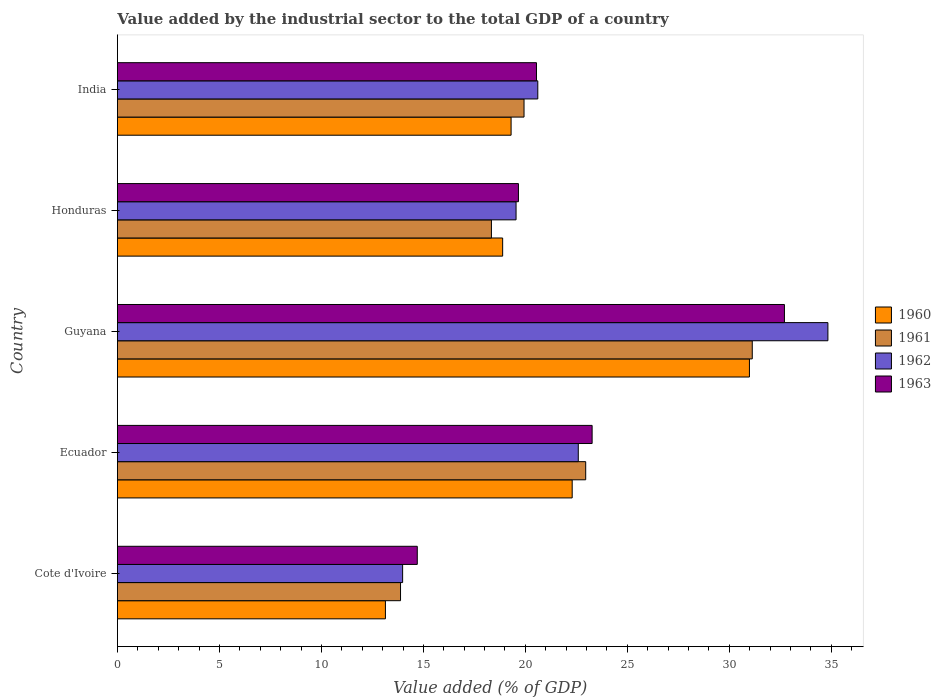How many different coloured bars are there?
Give a very brief answer. 4. How many groups of bars are there?
Make the answer very short. 5. Are the number of bars per tick equal to the number of legend labels?
Ensure brevity in your answer.  Yes. How many bars are there on the 2nd tick from the bottom?
Offer a very short reply. 4. What is the label of the 4th group of bars from the top?
Offer a terse response. Ecuador. In how many cases, is the number of bars for a given country not equal to the number of legend labels?
Offer a very short reply. 0. What is the value added by the industrial sector to the total GDP in 1963 in Cote d'Ivoire?
Provide a succinct answer. 14.7. Across all countries, what is the maximum value added by the industrial sector to the total GDP in 1963?
Keep it short and to the point. 32.7. Across all countries, what is the minimum value added by the industrial sector to the total GDP in 1963?
Ensure brevity in your answer.  14.7. In which country was the value added by the industrial sector to the total GDP in 1962 maximum?
Give a very brief answer. Guyana. In which country was the value added by the industrial sector to the total GDP in 1961 minimum?
Make the answer very short. Cote d'Ivoire. What is the total value added by the industrial sector to the total GDP in 1961 in the graph?
Offer a very short reply. 106.23. What is the difference between the value added by the industrial sector to the total GDP in 1963 in Cote d'Ivoire and that in India?
Make the answer very short. -5.84. What is the difference between the value added by the industrial sector to the total GDP in 1962 in Honduras and the value added by the industrial sector to the total GDP in 1963 in Ecuador?
Make the answer very short. -3.73. What is the average value added by the industrial sector to the total GDP in 1960 per country?
Keep it short and to the point. 20.92. What is the difference between the value added by the industrial sector to the total GDP in 1962 and value added by the industrial sector to the total GDP in 1960 in Cote d'Ivoire?
Your answer should be very brief. 0.84. What is the ratio of the value added by the industrial sector to the total GDP in 1963 in Guyana to that in Honduras?
Provide a succinct answer. 1.66. Is the value added by the industrial sector to the total GDP in 1963 in Ecuador less than that in India?
Offer a very short reply. No. What is the difference between the highest and the second highest value added by the industrial sector to the total GDP in 1960?
Ensure brevity in your answer.  8.69. What is the difference between the highest and the lowest value added by the industrial sector to the total GDP in 1961?
Give a very brief answer. 17.24. Is the sum of the value added by the industrial sector to the total GDP in 1961 in Ecuador and Guyana greater than the maximum value added by the industrial sector to the total GDP in 1962 across all countries?
Give a very brief answer. Yes. Is it the case that in every country, the sum of the value added by the industrial sector to the total GDP in 1962 and value added by the industrial sector to the total GDP in 1960 is greater than the sum of value added by the industrial sector to the total GDP in 1961 and value added by the industrial sector to the total GDP in 1963?
Offer a very short reply. No. What does the 2nd bar from the bottom in Cote d'Ivoire represents?
Provide a succinct answer. 1961. How many bars are there?
Provide a short and direct response. 20. Are all the bars in the graph horizontal?
Offer a very short reply. Yes. What is the difference between two consecutive major ticks on the X-axis?
Make the answer very short. 5. Are the values on the major ticks of X-axis written in scientific E-notation?
Make the answer very short. No. Does the graph contain any zero values?
Offer a terse response. No. How many legend labels are there?
Give a very brief answer. 4. What is the title of the graph?
Keep it short and to the point. Value added by the industrial sector to the total GDP of a country. What is the label or title of the X-axis?
Provide a succinct answer. Value added (% of GDP). What is the label or title of the Y-axis?
Keep it short and to the point. Country. What is the Value added (% of GDP) in 1960 in Cote d'Ivoire?
Your answer should be compact. 13.14. What is the Value added (% of GDP) in 1961 in Cote d'Ivoire?
Make the answer very short. 13.88. What is the Value added (% of GDP) of 1962 in Cote d'Ivoire?
Offer a very short reply. 13.98. What is the Value added (% of GDP) of 1963 in Cote d'Ivoire?
Your answer should be very brief. 14.7. What is the Value added (% of GDP) of 1960 in Ecuador?
Offer a very short reply. 22.29. What is the Value added (% of GDP) of 1961 in Ecuador?
Give a very brief answer. 22.96. What is the Value added (% of GDP) in 1962 in Ecuador?
Keep it short and to the point. 22.59. What is the Value added (% of GDP) in 1963 in Ecuador?
Ensure brevity in your answer.  23.27. What is the Value added (% of GDP) of 1960 in Guyana?
Give a very brief answer. 30.98. What is the Value added (% of GDP) of 1961 in Guyana?
Give a very brief answer. 31.12. What is the Value added (% of GDP) of 1962 in Guyana?
Your response must be concise. 34.83. What is the Value added (% of GDP) in 1963 in Guyana?
Offer a very short reply. 32.7. What is the Value added (% of GDP) in 1960 in Honduras?
Provide a succinct answer. 18.89. What is the Value added (% of GDP) in 1961 in Honduras?
Ensure brevity in your answer.  18.33. What is the Value added (% of GDP) in 1962 in Honduras?
Ensure brevity in your answer.  19.54. What is the Value added (% of GDP) of 1963 in Honduras?
Make the answer very short. 19.66. What is the Value added (% of GDP) of 1960 in India?
Make the answer very short. 19.3. What is the Value added (% of GDP) of 1961 in India?
Ensure brevity in your answer.  19.93. What is the Value added (% of GDP) of 1962 in India?
Keep it short and to the point. 20.61. What is the Value added (% of GDP) in 1963 in India?
Offer a terse response. 20.54. Across all countries, what is the maximum Value added (% of GDP) of 1960?
Your answer should be very brief. 30.98. Across all countries, what is the maximum Value added (% of GDP) in 1961?
Give a very brief answer. 31.12. Across all countries, what is the maximum Value added (% of GDP) in 1962?
Your answer should be very brief. 34.83. Across all countries, what is the maximum Value added (% of GDP) in 1963?
Offer a terse response. 32.7. Across all countries, what is the minimum Value added (% of GDP) of 1960?
Offer a terse response. 13.14. Across all countries, what is the minimum Value added (% of GDP) in 1961?
Your answer should be compact. 13.88. Across all countries, what is the minimum Value added (% of GDP) in 1962?
Your answer should be very brief. 13.98. Across all countries, what is the minimum Value added (% of GDP) of 1963?
Your answer should be compact. 14.7. What is the total Value added (% of GDP) in 1960 in the graph?
Your response must be concise. 104.6. What is the total Value added (% of GDP) of 1961 in the graph?
Keep it short and to the point. 106.23. What is the total Value added (% of GDP) of 1962 in the graph?
Ensure brevity in your answer.  111.56. What is the total Value added (% of GDP) in 1963 in the graph?
Keep it short and to the point. 110.87. What is the difference between the Value added (% of GDP) in 1960 in Cote d'Ivoire and that in Ecuador?
Ensure brevity in your answer.  -9.16. What is the difference between the Value added (% of GDP) in 1961 in Cote d'Ivoire and that in Ecuador?
Offer a terse response. -9.08. What is the difference between the Value added (% of GDP) of 1962 in Cote d'Ivoire and that in Ecuador?
Keep it short and to the point. -8.61. What is the difference between the Value added (% of GDP) of 1963 in Cote d'Ivoire and that in Ecuador?
Your answer should be very brief. -8.57. What is the difference between the Value added (% of GDP) in 1960 in Cote d'Ivoire and that in Guyana?
Your response must be concise. -17.84. What is the difference between the Value added (% of GDP) of 1961 in Cote d'Ivoire and that in Guyana?
Offer a very short reply. -17.24. What is the difference between the Value added (% of GDP) in 1962 in Cote d'Ivoire and that in Guyana?
Your answer should be very brief. -20.85. What is the difference between the Value added (% of GDP) in 1963 in Cote d'Ivoire and that in Guyana?
Make the answer very short. -18. What is the difference between the Value added (% of GDP) of 1960 in Cote d'Ivoire and that in Honduras?
Ensure brevity in your answer.  -5.75. What is the difference between the Value added (% of GDP) in 1961 in Cote d'Ivoire and that in Honduras?
Provide a succinct answer. -4.46. What is the difference between the Value added (% of GDP) of 1962 in Cote d'Ivoire and that in Honduras?
Your response must be concise. -5.56. What is the difference between the Value added (% of GDP) in 1963 in Cote d'Ivoire and that in Honduras?
Offer a terse response. -4.96. What is the difference between the Value added (% of GDP) of 1960 in Cote d'Ivoire and that in India?
Provide a short and direct response. -6.16. What is the difference between the Value added (% of GDP) of 1961 in Cote d'Ivoire and that in India?
Keep it short and to the point. -6.05. What is the difference between the Value added (% of GDP) of 1962 in Cote d'Ivoire and that in India?
Your answer should be very brief. -6.63. What is the difference between the Value added (% of GDP) of 1963 in Cote d'Ivoire and that in India?
Give a very brief answer. -5.84. What is the difference between the Value added (% of GDP) in 1960 in Ecuador and that in Guyana?
Provide a short and direct response. -8.69. What is the difference between the Value added (% of GDP) in 1961 in Ecuador and that in Guyana?
Offer a very short reply. -8.17. What is the difference between the Value added (% of GDP) of 1962 in Ecuador and that in Guyana?
Make the answer very short. -12.24. What is the difference between the Value added (% of GDP) in 1963 in Ecuador and that in Guyana?
Your answer should be compact. -9.43. What is the difference between the Value added (% of GDP) in 1960 in Ecuador and that in Honduras?
Provide a short and direct response. 3.41. What is the difference between the Value added (% of GDP) of 1961 in Ecuador and that in Honduras?
Offer a very short reply. 4.62. What is the difference between the Value added (% of GDP) of 1962 in Ecuador and that in Honduras?
Your answer should be very brief. 3.05. What is the difference between the Value added (% of GDP) of 1963 in Ecuador and that in Honduras?
Your answer should be very brief. 3.61. What is the difference between the Value added (% of GDP) in 1960 in Ecuador and that in India?
Give a very brief answer. 2.99. What is the difference between the Value added (% of GDP) of 1961 in Ecuador and that in India?
Your response must be concise. 3.02. What is the difference between the Value added (% of GDP) in 1962 in Ecuador and that in India?
Ensure brevity in your answer.  1.98. What is the difference between the Value added (% of GDP) in 1963 in Ecuador and that in India?
Give a very brief answer. 2.73. What is the difference between the Value added (% of GDP) of 1960 in Guyana and that in Honduras?
Your answer should be compact. 12.1. What is the difference between the Value added (% of GDP) in 1961 in Guyana and that in Honduras?
Provide a short and direct response. 12.79. What is the difference between the Value added (% of GDP) in 1962 in Guyana and that in Honduras?
Your answer should be very brief. 15.29. What is the difference between the Value added (% of GDP) in 1963 in Guyana and that in Honduras?
Provide a short and direct response. 13.04. What is the difference between the Value added (% of GDP) in 1960 in Guyana and that in India?
Provide a short and direct response. 11.68. What is the difference between the Value added (% of GDP) of 1961 in Guyana and that in India?
Your response must be concise. 11.19. What is the difference between the Value added (% of GDP) of 1962 in Guyana and that in India?
Make the answer very short. 14.22. What is the difference between the Value added (% of GDP) in 1963 in Guyana and that in India?
Your response must be concise. 12.15. What is the difference between the Value added (% of GDP) in 1960 in Honduras and that in India?
Make the answer very short. -0.41. What is the difference between the Value added (% of GDP) of 1961 in Honduras and that in India?
Provide a short and direct response. -1.6. What is the difference between the Value added (% of GDP) in 1962 in Honduras and that in India?
Make the answer very short. -1.07. What is the difference between the Value added (% of GDP) in 1963 in Honduras and that in India?
Your answer should be very brief. -0.88. What is the difference between the Value added (% of GDP) in 1960 in Cote d'Ivoire and the Value added (% of GDP) in 1961 in Ecuador?
Your response must be concise. -9.82. What is the difference between the Value added (% of GDP) of 1960 in Cote d'Ivoire and the Value added (% of GDP) of 1962 in Ecuador?
Ensure brevity in your answer.  -9.45. What is the difference between the Value added (% of GDP) of 1960 in Cote d'Ivoire and the Value added (% of GDP) of 1963 in Ecuador?
Your response must be concise. -10.13. What is the difference between the Value added (% of GDP) in 1961 in Cote d'Ivoire and the Value added (% of GDP) in 1962 in Ecuador?
Ensure brevity in your answer.  -8.71. What is the difference between the Value added (% of GDP) in 1961 in Cote d'Ivoire and the Value added (% of GDP) in 1963 in Ecuador?
Give a very brief answer. -9.39. What is the difference between the Value added (% of GDP) in 1962 in Cote d'Ivoire and the Value added (% of GDP) in 1963 in Ecuador?
Offer a very short reply. -9.29. What is the difference between the Value added (% of GDP) of 1960 in Cote d'Ivoire and the Value added (% of GDP) of 1961 in Guyana?
Offer a terse response. -17.98. What is the difference between the Value added (% of GDP) of 1960 in Cote d'Ivoire and the Value added (% of GDP) of 1962 in Guyana?
Offer a terse response. -21.69. What is the difference between the Value added (% of GDP) of 1960 in Cote d'Ivoire and the Value added (% of GDP) of 1963 in Guyana?
Offer a very short reply. -19.56. What is the difference between the Value added (% of GDP) in 1961 in Cote d'Ivoire and the Value added (% of GDP) in 1962 in Guyana?
Your response must be concise. -20.95. What is the difference between the Value added (% of GDP) of 1961 in Cote d'Ivoire and the Value added (% of GDP) of 1963 in Guyana?
Provide a succinct answer. -18.82. What is the difference between the Value added (% of GDP) of 1962 in Cote d'Ivoire and the Value added (% of GDP) of 1963 in Guyana?
Keep it short and to the point. -18.72. What is the difference between the Value added (% of GDP) of 1960 in Cote d'Ivoire and the Value added (% of GDP) of 1961 in Honduras?
Offer a very short reply. -5.2. What is the difference between the Value added (% of GDP) of 1960 in Cote d'Ivoire and the Value added (% of GDP) of 1962 in Honduras?
Offer a very short reply. -6.4. What is the difference between the Value added (% of GDP) in 1960 in Cote d'Ivoire and the Value added (% of GDP) in 1963 in Honduras?
Keep it short and to the point. -6.52. What is the difference between the Value added (% of GDP) of 1961 in Cote d'Ivoire and the Value added (% of GDP) of 1962 in Honduras?
Make the answer very short. -5.66. What is the difference between the Value added (% of GDP) in 1961 in Cote d'Ivoire and the Value added (% of GDP) in 1963 in Honduras?
Offer a terse response. -5.78. What is the difference between the Value added (% of GDP) in 1962 in Cote d'Ivoire and the Value added (% of GDP) in 1963 in Honduras?
Offer a terse response. -5.68. What is the difference between the Value added (% of GDP) in 1960 in Cote d'Ivoire and the Value added (% of GDP) in 1961 in India?
Offer a terse response. -6.79. What is the difference between the Value added (% of GDP) in 1960 in Cote d'Ivoire and the Value added (% of GDP) in 1962 in India?
Your answer should be compact. -7.47. What is the difference between the Value added (% of GDP) in 1960 in Cote d'Ivoire and the Value added (% of GDP) in 1963 in India?
Your response must be concise. -7.41. What is the difference between the Value added (% of GDP) of 1961 in Cote d'Ivoire and the Value added (% of GDP) of 1962 in India?
Make the answer very short. -6.73. What is the difference between the Value added (% of GDP) in 1961 in Cote d'Ivoire and the Value added (% of GDP) in 1963 in India?
Give a very brief answer. -6.66. What is the difference between the Value added (% of GDP) in 1962 in Cote d'Ivoire and the Value added (% of GDP) in 1963 in India?
Give a very brief answer. -6.56. What is the difference between the Value added (% of GDP) of 1960 in Ecuador and the Value added (% of GDP) of 1961 in Guyana?
Ensure brevity in your answer.  -8.83. What is the difference between the Value added (% of GDP) in 1960 in Ecuador and the Value added (% of GDP) in 1962 in Guyana?
Your answer should be compact. -12.54. What is the difference between the Value added (% of GDP) in 1960 in Ecuador and the Value added (% of GDP) in 1963 in Guyana?
Give a very brief answer. -10.4. What is the difference between the Value added (% of GDP) in 1961 in Ecuador and the Value added (% of GDP) in 1962 in Guyana?
Your response must be concise. -11.87. What is the difference between the Value added (% of GDP) in 1961 in Ecuador and the Value added (% of GDP) in 1963 in Guyana?
Offer a terse response. -9.74. What is the difference between the Value added (% of GDP) of 1962 in Ecuador and the Value added (% of GDP) of 1963 in Guyana?
Ensure brevity in your answer.  -10.11. What is the difference between the Value added (% of GDP) of 1960 in Ecuador and the Value added (% of GDP) of 1961 in Honduras?
Provide a short and direct response. 3.96. What is the difference between the Value added (% of GDP) in 1960 in Ecuador and the Value added (% of GDP) in 1962 in Honduras?
Your answer should be very brief. 2.75. What is the difference between the Value added (% of GDP) of 1960 in Ecuador and the Value added (% of GDP) of 1963 in Honduras?
Ensure brevity in your answer.  2.64. What is the difference between the Value added (% of GDP) in 1961 in Ecuador and the Value added (% of GDP) in 1962 in Honduras?
Your answer should be compact. 3.41. What is the difference between the Value added (% of GDP) of 1961 in Ecuador and the Value added (% of GDP) of 1963 in Honduras?
Your answer should be very brief. 3.3. What is the difference between the Value added (% of GDP) in 1962 in Ecuador and the Value added (% of GDP) in 1963 in Honduras?
Offer a terse response. 2.93. What is the difference between the Value added (% of GDP) of 1960 in Ecuador and the Value added (% of GDP) of 1961 in India?
Offer a very short reply. 2.36. What is the difference between the Value added (% of GDP) in 1960 in Ecuador and the Value added (% of GDP) in 1962 in India?
Provide a short and direct response. 1.69. What is the difference between the Value added (% of GDP) in 1960 in Ecuador and the Value added (% of GDP) in 1963 in India?
Make the answer very short. 1.75. What is the difference between the Value added (% of GDP) in 1961 in Ecuador and the Value added (% of GDP) in 1962 in India?
Your response must be concise. 2.35. What is the difference between the Value added (% of GDP) in 1961 in Ecuador and the Value added (% of GDP) in 1963 in India?
Make the answer very short. 2.41. What is the difference between the Value added (% of GDP) in 1962 in Ecuador and the Value added (% of GDP) in 1963 in India?
Your answer should be compact. 2.05. What is the difference between the Value added (% of GDP) of 1960 in Guyana and the Value added (% of GDP) of 1961 in Honduras?
Offer a very short reply. 12.65. What is the difference between the Value added (% of GDP) in 1960 in Guyana and the Value added (% of GDP) in 1962 in Honduras?
Provide a short and direct response. 11.44. What is the difference between the Value added (% of GDP) of 1960 in Guyana and the Value added (% of GDP) of 1963 in Honduras?
Provide a short and direct response. 11.32. What is the difference between the Value added (% of GDP) in 1961 in Guyana and the Value added (% of GDP) in 1962 in Honduras?
Offer a very short reply. 11.58. What is the difference between the Value added (% of GDP) in 1961 in Guyana and the Value added (% of GDP) in 1963 in Honduras?
Your response must be concise. 11.46. What is the difference between the Value added (% of GDP) in 1962 in Guyana and the Value added (% of GDP) in 1963 in Honduras?
Give a very brief answer. 15.17. What is the difference between the Value added (% of GDP) in 1960 in Guyana and the Value added (% of GDP) in 1961 in India?
Offer a very short reply. 11.05. What is the difference between the Value added (% of GDP) in 1960 in Guyana and the Value added (% of GDP) in 1962 in India?
Offer a very short reply. 10.37. What is the difference between the Value added (% of GDP) of 1960 in Guyana and the Value added (% of GDP) of 1963 in India?
Give a very brief answer. 10.44. What is the difference between the Value added (% of GDP) in 1961 in Guyana and the Value added (% of GDP) in 1962 in India?
Ensure brevity in your answer.  10.51. What is the difference between the Value added (% of GDP) in 1961 in Guyana and the Value added (% of GDP) in 1963 in India?
Make the answer very short. 10.58. What is the difference between the Value added (% of GDP) in 1962 in Guyana and the Value added (% of GDP) in 1963 in India?
Offer a very short reply. 14.29. What is the difference between the Value added (% of GDP) of 1960 in Honduras and the Value added (% of GDP) of 1961 in India?
Offer a very short reply. -1.05. What is the difference between the Value added (% of GDP) of 1960 in Honduras and the Value added (% of GDP) of 1962 in India?
Your response must be concise. -1.72. What is the difference between the Value added (% of GDP) in 1960 in Honduras and the Value added (% of GDP) in 1963 in India?
Your answer should be very brief. -1.66. What is the difference between the Value added (% of GDP) of 1961 in Honduras and the Value added (% of GDP) of 1962 in India?
Give a very brief answer. -2.27. What is the difference between the Value added (% of GDP) of 1961 in Honduras and the Value added (% of GDP) of 1963 in India?
Your answer should be very brief. -2.21. What is the difference between the Value added (% of GDP) of 1962 in Honduras and the Value added (% of GDP) of 1963 in India?
Offer a very short reply. -1. What is the average Value added (% of GDP) in 1960 per country?
Offer a very short reply. 20.92. What is the average Value added (% of GDP) in 1961 per country?
Keep it short and to the point. 21.25. What is the average Value added (% of GDP) of 1962 per country?
Your answer should be compact. 22.31. What is the average Value added (% of GDP) in 1963 per country?
Ensure brevity in your answer.  22.17. What is the difference between the Value added (% of GDP) of 1960 and Value added (% of GDP) of 1961 in Cote d'Ivoire?
Keep it short and to the point. -0.74. What is the difference between the Value added (% of GDP) of 1960 and Value added (% of GDP) of 1962 in Cote d'Ivoire?
Provide a short and direct response. -0.84. What is the difference between the Value added (% of GDP) of 1960 and Value added (% of GDP) of 1963 in Cote d'Ivoire?
Provide a short and direct response. -1.56. What is the difference between the Value added (% of GDP) of 1961 and Value added (% of GDP) of 1962 in Cote d'Ivoire?
Provide a succinct answer. -0.1. What is the difference between the Value added (% of GDP) of 1961 and Value added (% of GDP) of 1963 in Cote d'Ivoire?
Offer a terse response. -0.82. What is the difference between the Value added (% of GDP) of 1962 and Value added (% of GDP) of 1963 in Cote d'Ivoire?
Your answer should be very brief. -0.72. What is the difference between the Value added (% of GDP) of 1960 and Value added (% of GDP) of 1961 in Ecuador?
Your answer should be compact. -0.66. What is the difference between the Value added (% of GDP) of 1960 and Value added (% of GDP) of 1962 in Ecuador?
Make the answer very short. -0.3. What is the difference between the Value added (% of GDP) in 1960 and Value added (% of GDP) in 1963 in Ecuador?
Offer a terse response. -0.98. What is the difference between the Value added (% of GDP) of 1961 and Value added (% of GDP) of 1962 in Ecuador?
Provide a short and direct response. 0.36. What is the difference between the Value added (% of GDP) in 1961 and Value added (% of GDP) in 1963 in Ecuador?
Provide a succinct answer. -0.31. What is the difference between the Value added (% of GDP) in 1962 and Value added (% of GDP) in 1963 in Ecuador?
Your answer should be compact. -0.68. What is the difference between the Value added (% of GDP) in 1960 and Value added (% of GDP) in 1961 in Guyana?
Provide a succinct answer. -0.14. What is the difference between the Value added (% of GDP) in 1960 and Value added (% of GDP) in 1962 in Guyana?
Keep it short and to the point. -3.85. What is the difference between the Value added (% of GDP) in 1960 and Value added (% of GDP) in 1963 in Guyana?
Offer a very short reply. -1.72. What is the difference between the Value added (% of GDP) in 1961 and Value added (% of GDP) in 1962 in Guyana?
Keep it short and to the point. -3.71. What is the difference between the Value added (% of GDP) in 1961 and Value added (% of GDP) in 1963 in Guyana?
Offer a terse response. -1.58. What is the difference between the Value added (% of GDP) in 1962 and Value added (% of GDP) in 1963 in Guyana?
Keep it short and to the point. 2.13. What is the difference between the Value added (% of GDP) of 1960 and Value added (% of GDP) of 1961 in Honduras?
Make the answer very short. 0.55. What is the difference between the Value added (% of GDP) of 1960 and Value added (% of GDP) of 1962 in Honduras?
Keep it short and to the point. -0.66. What is the difference between the Value added (% of GDP) of 1960 and Value added (% of GDP) of 1963 in Honduras?
Your answer should be compact. -0.77. What is the difference between the Value added (% of GDP) in 1961 and Value added (% of GDP) in 1962 in Honduras?
Offer a very short reply. -1.21. What is the difference between the Value added (% of GDP) of 1961 and Value added (% of GDP) of 1963 in Honduras?
Provide a succinct answer. -1.32. What is the difference between the Value added (% of GDP) in 1962 and Value added (% of GDP) in 1963 in Honduras?
Make the answer very short. -0.12. What is the difference between the Value added (% of GDP) of 1960 and Value added (% of GDP) of 1961 in India?
Provide a short and direct response. -0.63. What is the difference between the Value added (% of GDP) of 1960 and Value added (% of GDP) of 1962 in India?
Make the answer very short. -1.31. What is the difference between the Value added (% of GDP) of 1960 and Value added (% of GDP) of 1963 in India?
Ensure brevity in your answer.  -1.24. What is the difference between the Value added (% of GDP) of 1961 and Value added (% of GDP) of 1962 in India?
Keep it short and to the point. -0.68. What is the difference between the Value added (% of GDP) of 1961 and Value added (% of GDP) of 1963 in India?
Ensure brevity in your answer.  -0.61. What is the difference between the Value added (% of GDP) of 1962 and Value added (% of GDP) of 1963 in India?
Offer a terse response. 0.06. What is the ratio of the Value added (% of GDP) of 1960 in Cote d'Ivoire to that in Ecuador?
Give a very brief answer. 0.59. What is the ratio of the Value added (% of GDP) of 1961 in Cote d'Ivoire to that in Ecuador?
Ensure brevity in your answer.  0.6. What is the ratio of the Value added (% of GDP) of 1962 in Cote d'Ivoire to that in Ecuador?
Offer a terse response. 0.62. What is the ratio of the Value added (% of GDP) in 1963 in Cote d'Ivoire to that in Ecuador?
Offer a very short reply. 0.63. What is the ratio of the Value added (% of GDP) of 1960 in Cote d'Ivoire to that in Guyana?
Give a very brief answer. 0.42. What is the ratio of the Value added (% of GDP) in 1961 in Cote d'Ivoire to that in Guyana?
Give a very brief answer. 0.45. What is the ratio of the Value added (% of GDP) of 1962 in Cote d'Ivoire to that in Guyana?
Offer a terse response. 0.4. What is the ratio of the Value added (% of GDP) of 1963 in Cote d'Ivoire to that in Guyana?
Make the answer very short. 0.45. What is the ratio of the Value added (% of GDP) of 1960 in Cote d'Ivoire to that in Honduras?
Your answer should be compact. 0.7. What is the ratio of the Value added (% of GDP) in 1961 in Cote d'Ivoire to that in Honduras?
Ensure brevity in your answer.  0.76. What is the ratio of the Value added (% of GDP) in 1962 in Cote d'Ivoire to that in Honduras?
Keep it short and to the point. 0.72. What is the ratio of the Value added (% of GDP) of 1963 in Cote d'Ivoire to that in Honduras?
Your answer should be very brief. 0.75. What is the ratio of the Value added (% of GDP) in 1960 in Cote d'Ivoire to that in India?
Provide a succinct answer. 0.68. What is the ratio of the Value added (% of GDP) of 1961 in Cote d'Ivoire to that in India?
Provide a succinct answer. 0.7. What is the ratio of the Value added (% of GDP) of 1962 in Cote d'Ivoire to that in India?
Your answer should be compact. 0.68. What is the ratio of the Value added (% of GDP) of 1963 in Cote d'Ivoire to that in India?
Make the answer very short. 0.72. What is the ratio of the Value added (% of GDP) of 1960 in Ecuador to that in Guyana?
Ensure brevity in your answer.  0.72. What is the ratio of the Value added (% of GDP) in 1961 in Ecuador to that in Guyana?
Make the answer very short. 0.74. What is the ratio of the Value added (% of GDP) of 1962 in Ecuador to that in Guyana?
Keep it short and to the point. 0.65. What is the ratio of the Value added (% of GDP) of 1963 in Ecuador to that in Guyana?
Your answer should be compact. 0.71. What is the ratio of the Value added (% of GDP) in 1960 in Ecuador to that in Honduras?
Offer a terse response. 1.18. What is the ratio of the Value added (% of GDP) of 1961 in Ecuador to that in Honduras?
Your response must be concise. 1.25. What is the ratio of the Value added (% of GDP) in 1962 in Ecuador to that in Honduras?
Offer a very short reply. 1.16. What is the ratio of the Value added (% of GDP) in 1963 in Ecuador to that in Honduras?
Provide a succinct answer. 1.18. What is the ratio of the Value added (% of GDP) in 1960 in Ecuador to that in India?
Provide a short and direct response. 1.16. What is the ratio of the Value added (% of GDP) of 1961 in Ecuador to that in India?
Your answer should be very brief. 1.15. What is the ratio of the Value added (% of GDP) of 1962 in Ecuador to that in India?
Your response must be concise. 1.1. What is the ratio of the Value added (% of GDP) in 1963 in Ecuador to that in India?
Give a very brief answer. 1.13. What is the ratio of the Value added (% of GDP) of 1960 in Guyana to that in Honduras?
Make the answer very short. 1.64. What is the ratio of the Value added (% of GDP) of 1961 in Guyana to that in Honduras?
Ensure brevity in your answer.  1.7. What is the ratio of the Value added (% of GDP) in 1962 in Guyana to that in Honduras?
Provide a succinct answer. 1.78. What is the ratio of the Value added (% of GDP) of 1963 in Guyana to that in Honduras?
Provide a succinct answer. 1.66. What is the ratio of the Value added (% of GDP) of 1960 in Guyana to that in India?
Ensure brevity in your answer.  1.61. What is the ratio of the Value added (% of GDP) in 1961 in Guyana to that in India?
Keep it short and to the point. 1.56. What is the ratio of the Value added (% of GDP) of 1962 in Guyana to that in India?
Your answer should be very brief. 1.69. What is the ratio of the Value added (% of GDP) of 1963 in Guyana to that in India?
Offer a terse response. 1.59. What is the ratio of the Value added (% of GDP) of 1960 in Honduras to that in India?
Offer a terse response. 0.98. What is the ratio of the Value added (% of GDP) in 1961 in Honduras to that in India?
Make the answer very short. 0.92. What is the ratio of the Value added (% of GDP) in 1962 in Honduras to that in India?
Keep it short and to the point. 0.95. What is the ratio of the Value added (% of GDP) of 1963 in Honduras to that in India?
Offer a terse response. 0.96. What is the difference between the highest and the second highest Value added (% of GDP) in 1960?
Your answer should be very brief. 8.69. What is the difference between the highest and the second highest Value added (% of GDP) of 1961?
Make the answer very short. 8.17. What is the difference between the highest and the second highest Value added (% of GDP) in 1962?
Offer a very short reply. 12.24. What is the difference between the highest and the second highest Value added (% of GDP) of 1963?
Ensure brevity in your answer.  9.43. What is the difference between the highest and the lowest Value added (% of GDP) in 1960?
Offer a very short reply. 17.84. What is the difference between the highest and the lowest Value added (% of GDP) in 1961?
Offer a terse response. 17.24. What is the difference between the highest and the lowest Value added (% of GDP) in 1962?
Ensure brevity in your answer.  20.85. What is the difference between the highest and the lowest Value added (% of GDP) in 1963?
Provide a short and direct response. 18. 